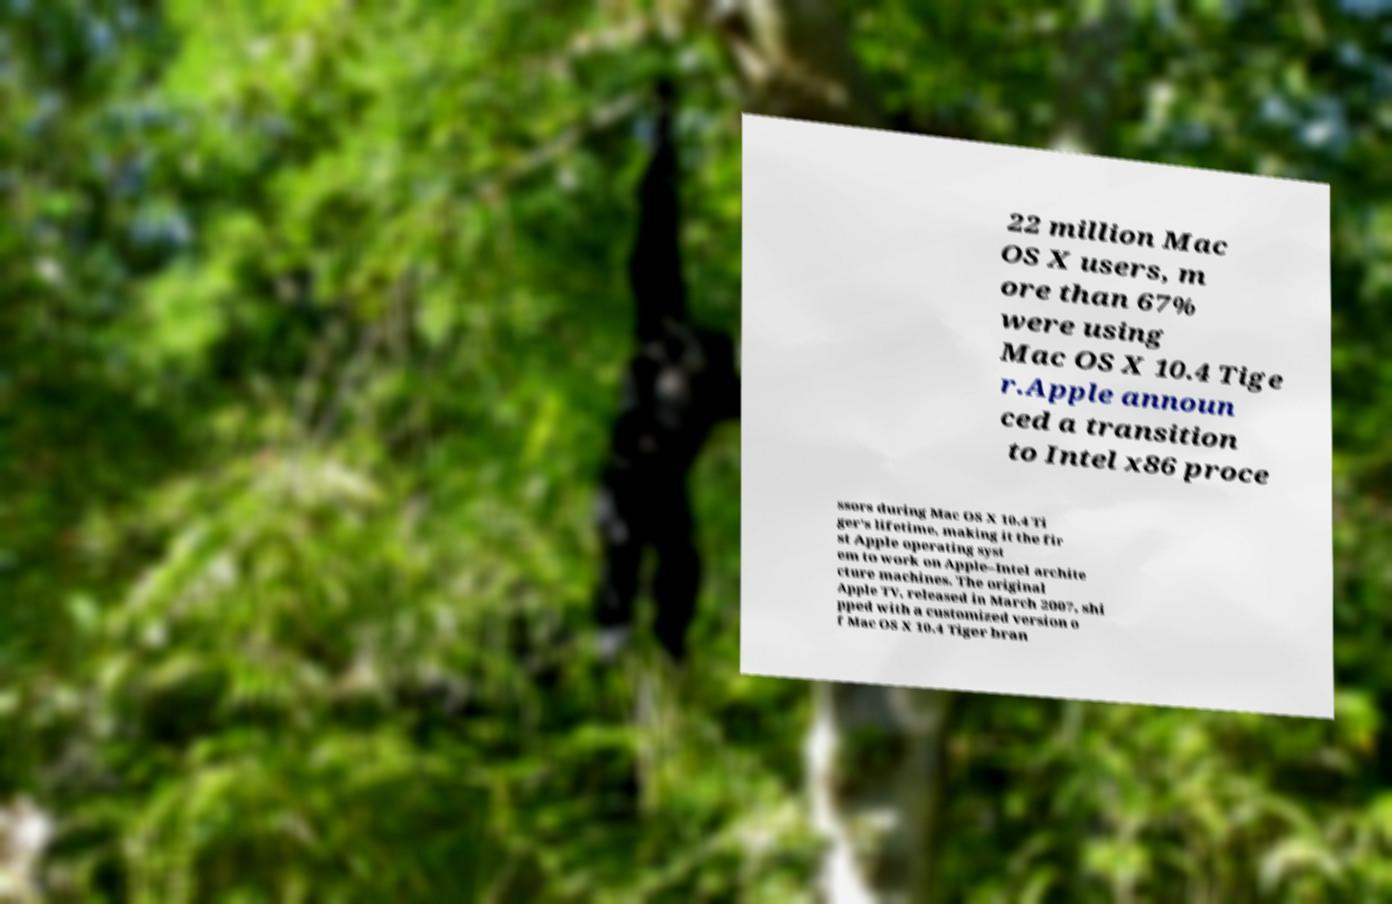What messages or text are displayed in this image? I need them in a readable, typed format. 22 million Mac OS X users, m ore than 67% were using Mac OS X 10.4 Tige r.Apple announ ced a transition to Intel x86 proce ssors during Mac OS X 10.4 Ti ger's lifetime, making it the fir st Apple operating syst em to work on Apple–Intel archite cture machines. The original Apple TV, released in March 2007, shi pped with a customized version o f Mac OS X 10.4 Tiger bran 